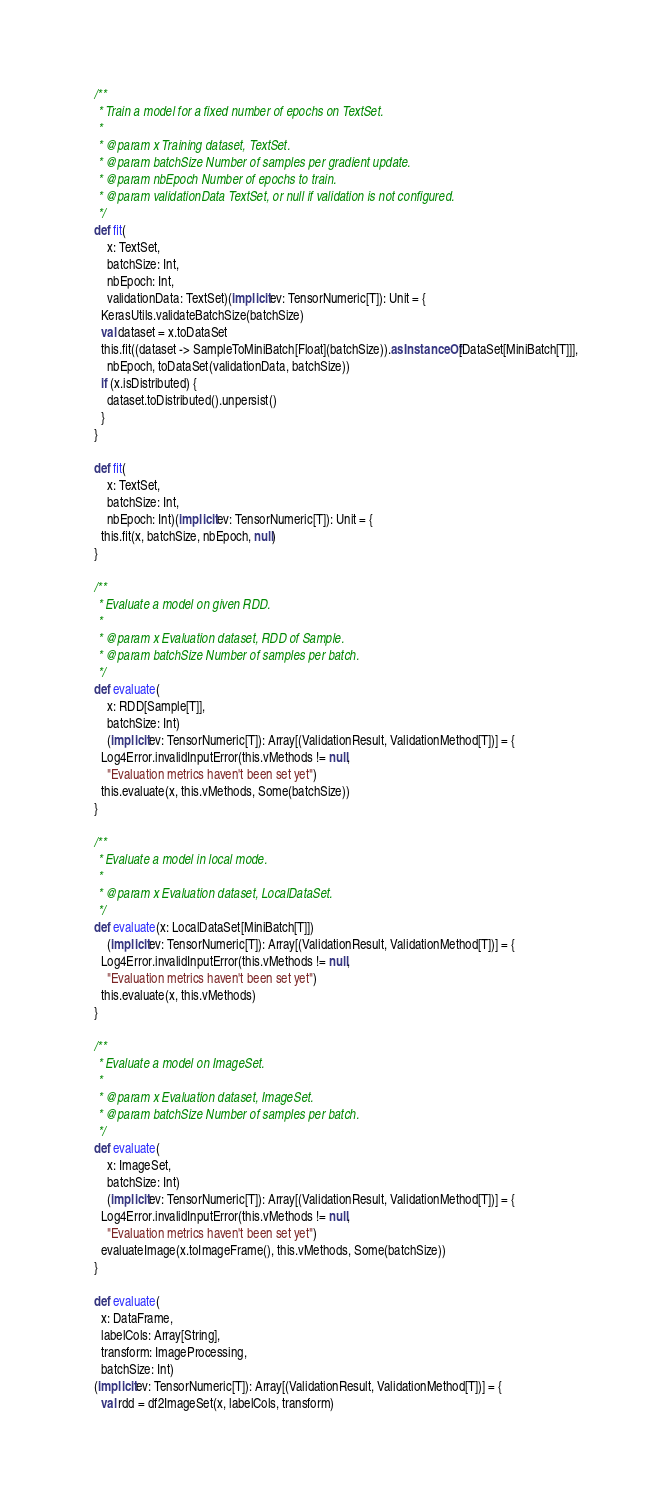Convert code to text. <code><loc_0><loc_0><loc_500><loc_500><_Scala_>
  /**
   * Train a model for a fixed number of epochs on TextSet.
   *
   * @param x Training dataset, TextSet.
   * @param batchSize Number of samples per gradient update.
   * @param nbEpoch Number of epochs to train.
   * @param validationData TextSet, or null if validation is not configured.
   */
  def fit(
      x: TextSet,
      batchSize: Int,
      nbEpoch: Int,
      validationData: TextSet)(implicit ev: TensorNumeric[T]): Unit = {
    KerasUtils.validateBatchSize(batchSize)
    val dataset = x.toDataSet
    this.fit((dataset -> SampleToMiniBatch[Float](batchSize)).asInstanceOf[DataSet[MiniBatch[T]]],
      nbEpoch, toDataSet(validationData, batchSize))
    if (x.isDistributed) {
      dataset.toDistributed().unpersist()
    }
  }

  def fit(
      x: TextSet,
      batchSize: Int,
      nbEpoch: Int)(implicit ev: TensorNumeric[T]): Unit = {
    this.fit(x, batchSize, nbEpoch, null)
  }

  /**
   * Evaluate a model on given RDD.
   *
   * @param x Evaluation dataset, RDD of Sample.
   * @param batchSize Number of samples per batch.
   */
  def evaluate(
      x: RDD[Sample[T]],
      batchSize: Int)
      (implicit ev: TensorNumeric[T]): Array[(ValidationResult, ValidationMethod[T])] = {
    Log4Error.invalidInputError(this.vMethods != null,
      "Evaluation metrics haven't been set yet")
    this.evaluate(x, this.vMethods, Some(batchSize))
  }

  /**
   * Evaluate a model in local mode.
   *
   * @param x Evaluation dataset, LocalDataSet.
   */
  def evaluate(x: LocalDataSet[MiniBatch[T]])
      (implicit ev: TensorNumeric[T]): Array[(ValidationResult, ValidationMethod[T])] = {
    Log4Error.invalidInputError(this.vMethods != null,
      "Evaluation metrics haven't been set yet")
    this.evaluate(x, this.vMethods)
  }

  /**
   * Evaluate a model on ImageSet.
   *
   * @param x Evaluation dataset, ImageSet.
   * @param batchSize Number of samples per batch.
   */
  def evaluate(
      x: ImageSet,
      batchSize: Int)
      (implicit ev: TensorNumeric[T]): Array[(ValidationResult, ValidationMethod[T])] = {
    Log4Error.invalidInputError(this.vMethods != null,
      "Evaluation metrics haven't been set yet")
    evaluateImage(x.toImageFrame(), this.vMethods, Some(batchSize))
  }

  def evaluate(
    x: DataFrame,
    labelCols: Array[String],
    transform: ImageProcessing,
    batchSize: Int)
  (implicit ev: TensorNumeric[T]): Array[(ValidationResult, ValidationMethod[T])] = {
    val rdd = df2ImageSet(x, labelCols, transform)</code> 